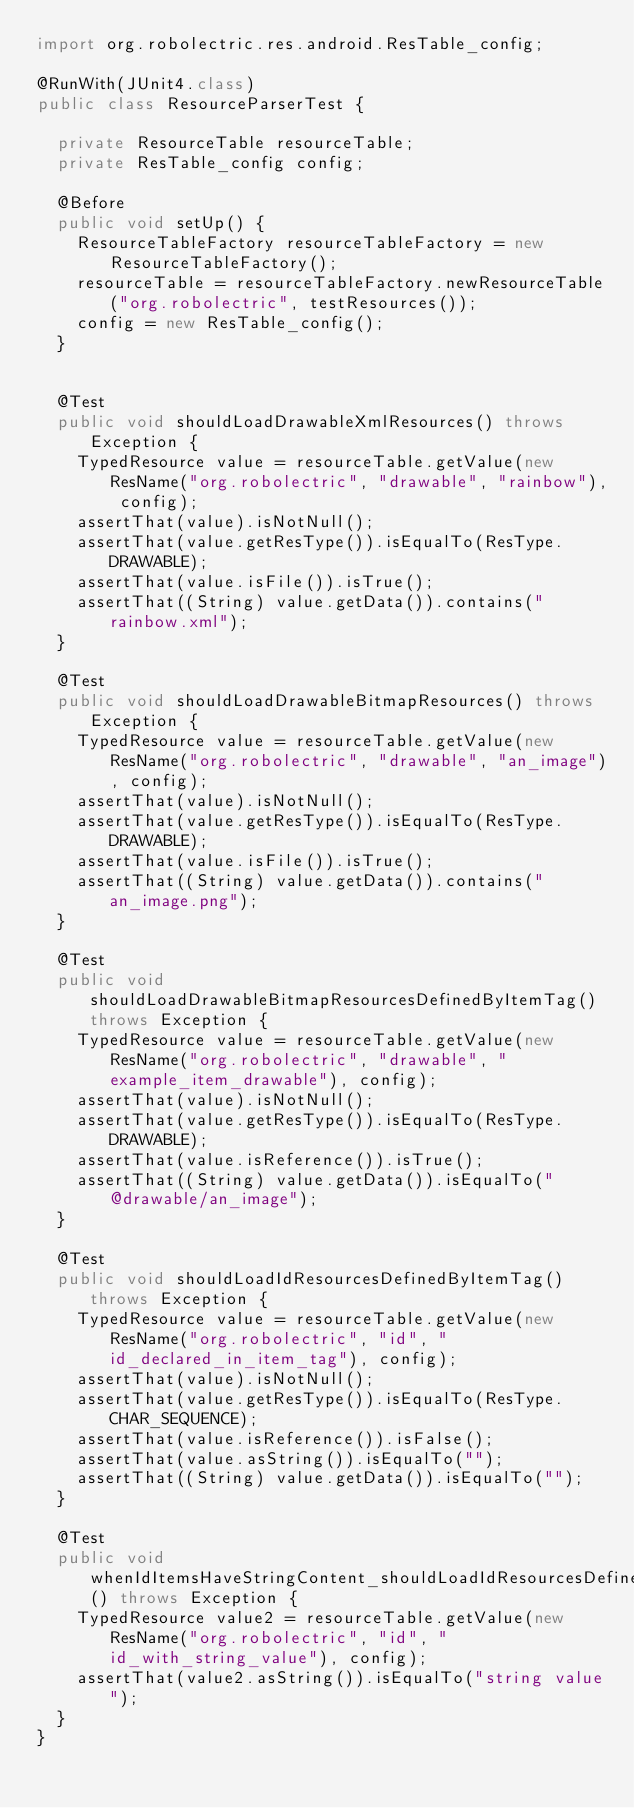Convert code to text. <code><loc_0><loc_0><loc_500><loc_500><_Java_>import org.robolectric.res.android.ResTable_config;

@RunWith(JUnit4.class)
public class ResourceParserTest {

  private ResourceTable resourceTable;
  private ResTable_config config;

  @Before
  public void setUp() {
    ResourceTableFactory resourceTableFactory = new ResourceTableFactory();
    resourceTable = resourceTableFactory.newResourceTable("org.robolectric", testResources());
    config = new ResTable_config();
  }


  @Test
  public void shouldLoadDrawableXmlResources() throws Exception {
    TypedResource value = resourceTable.getValue(new ResName("org.robolectric", "drawable", "rainbow"), config);
    assertThat(value).isNotNull();
    assertThat(value.getResType()).isEqualTo(ResType.DRAWABLE);
    assertThat(value.isFile()).isTrue();
    assertThat((String) value.getData()).contains("rainbow.xml");
  }

  @Test
  public void shouldLoadDrawableBitmapResources() throws Exception {
    TypedResource value = resourceTable.getValue(new ResName("org.robolectric", "drawable", "an_image"), config);
    assertThat(value).isNotNull();
    assertThat(value.getResType()).isEqualTo(ResType.DRAWABLE);
    assertThat(value.isFile()).isTrue();
    assertThat((String) value.getData()).contains("an_image.png");
  }

  @Test
  public void shouldLoadDrawableBitmapResourcesDefinedByItemTag() throws Exception {
    TypedResource value = resourceTable.getValue(new ResName("org.robolectric", "drawable", "example_item_drawable"), config);
    assertThat(value).isNotNull();
    assertThat(value.getResType()).isEqualTo(ResType.DRAWABLE);
    assertThat(value.isReference()).isTrue();
    assertThat((String) value.getData()).isEqualTo("@drawable/an_image");
  }

  @Test
  public void shouldLoadIdResourcesDefinedByItemTag() throws Exception {
    TypedResource value = resourceTable.getValue(new ResName("org.robolectric", "id", "id_declared_in_item_tag"), config);
    assertThat(value).isNotNull();
    assertThat(value.getResType()).isEqualTo(ResType.CHAR_SEQUENCE);
    assertThat(value.isReference()).isFalse();
    assertThat(value.asString()).isEqualTo("");
    assertThat((String) value.getData()).isEqualTo("");
  }

  @Test
  public void whenIdItemsHaveStringContent_shouldLoadIdResourcesDefinedByItemTag() throws Exception {
    TypedResource value2 = resourceTable.getValue(new ResName("org.robolectric", "id", "id_with_string_value"), config);
    assertThat(value2.asString()).isEqualTo("string value");
  }
}
</code> 